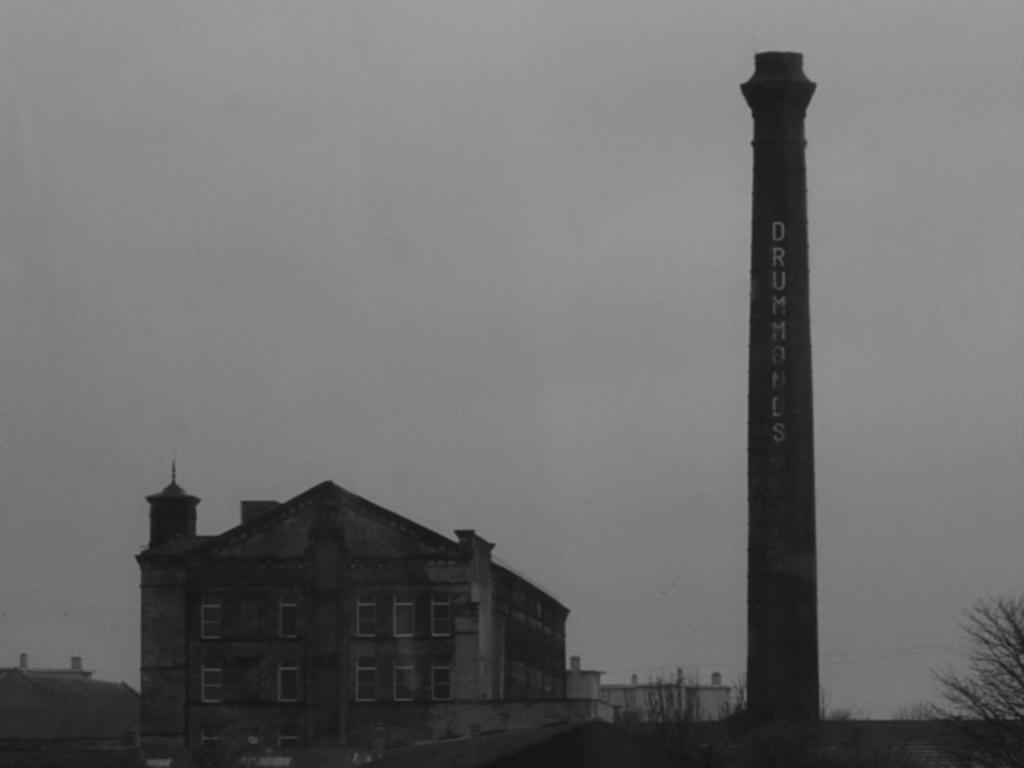Can you describe this image briefly? In this picture there are few buildings and there is a tower beside it and there is a tree which has no leaves in the right corner. 